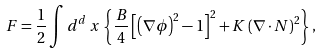<formula> <loc_0><loc_0><loc_500><loc_500>F = \frac { 1 } { 2 } \int d ^ { d } \, x \, \left \{ \frac { B } { 4 } \left [ \left ( \nabla \phi \right ) ^ { 2 } - 1 \right ] ^ { 2 } + K \left ( \nabla \cdot { N } \right ) ^ { 2 } \right \} ,</formula> 